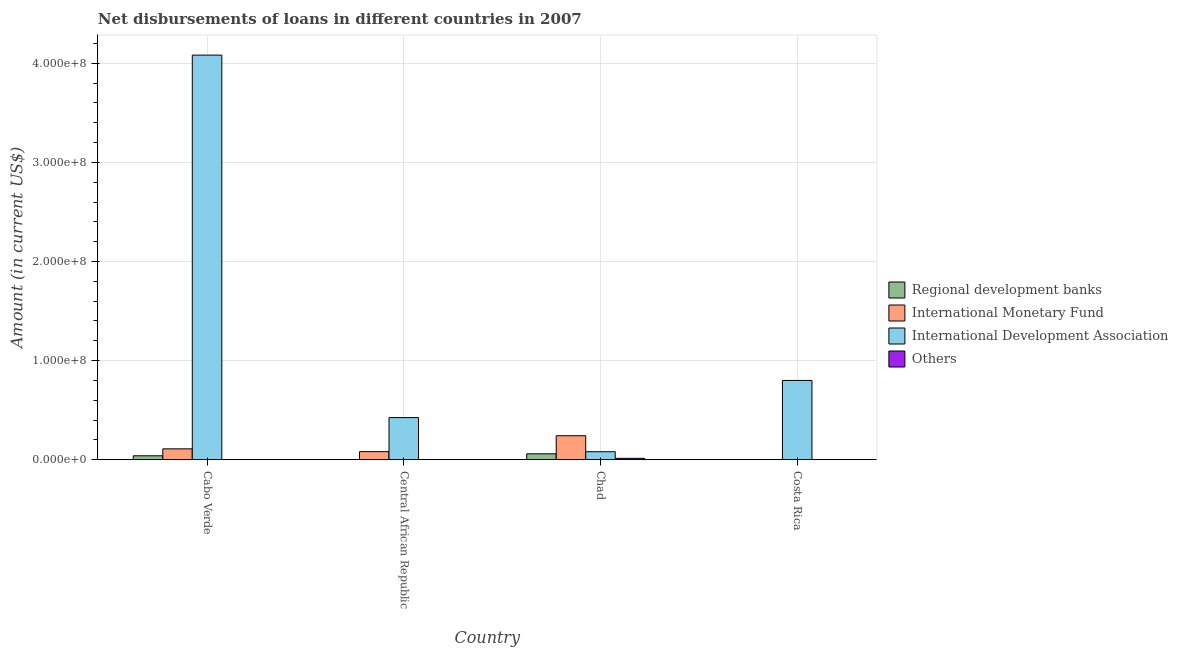How many different coloured bars are there?
Give a very brief answer. 4. Are the number of bars on each tick of the X-axis equal?
Offer a very short reply. No. How many bars are there on the 4th tick from the left?
Offer a terse response. 1. How many bars are there on the 4th tick from the right?
Your answer should be compact. 3. What is the label of the 2nd group of bars from the left?
Give a very brief answer. Central African Republic. In how many cases, is the number of bars for a given country not equal to the number of legend labels?
Your answer should be compact. 3. Across all countries, what is the maximum amount of loan disimbursed by international monetary fund?
Provide a short and direct response. 2.42e+07. In which country was the amount of loan disimbursed by international monetary fund maximum?
Ensure brevity in your answer.  Chad. What is the total amount of loan disimbursed by other organisations in the graph?
Your response must be concise. 1.40e+06. What is the difference between the amount of loan disimbursed by international monetary fund in Cabo Verde and that in Central African Republic?
Your answer should be very brief. 2.83e+06. What is the difference between the amount of loan disimbursed by international monetary fund in Central African Republic and the amount of loan disimbursed by other organisations in Cabo Verde?
Provide a succinct answer. 8.11e+06. What is the average amount of loan disimbursed by regional development banks per country?
Your answer should be very brief. 2.47e+06. What is the difference between the amount of loan disimbursed by regional development banks and amount of loan disimbursed by international development association in Chad?
Give a very brief answer. -2.12e+06. What is the ratio of the amount of loan disimbursed by international development association in Cabo Verde to that in Central African Republic?
Your answer should be compact. 9.61. Is the amount of loan disimbursed by international development association in Cabo Verde less than that in Chad?
Your answer should be compact. No. What is the difference between the highest and the second highest amount of loan disimbursed by international monetary fund?
Provide a succinct answer. 1.32e+07. What is the difference between the highest and the lowest amount of loan disimbursed by regional development banks?
Ensure brevity in your answer.  5.93e+06. In how many countries, is the amount of loan disimbursed by international development association greater than the average amount of loan disimbursed by international development association taken over all countries?
Ensure brevity in your answer.  1. Is the sum of the amount of loan disimbursed by international monetary fund in Central African Republic and Chad greater than the maximum amount of loan disimbursed by other organisations across all countries?
Ensure brevity in your answer.  Yes. Are the values on the major ticks of Y-axis written in scientific E-notation?
Offer a terse response. Yes. Does the graph contain any zero values?
Ensure brevity in your answer.  Yes. Where does the legend appear in the graph?
Provide a succinct answer. Center right. How many legend labels are there?
Provide a succinct answer. 4. How are the legend labels stacked?
Your answer should be very brief. Vertical. What is the title of the graph?
Make the answer very short. Net disbursements of loans in different countries in 2007. Does "Social Insurance" appear as one of the legend labels in the graph?
Keep it short and to the point. No. What is the Amount (in current US$) in Regional development banks in Cabo Verde?
Give a very brief answer. 3.94e+06. What is the Amount (in current US$) of International Monetary Fund in Cabo Verde?
Provide a short and direct response. 1.09e+07. What is the Amount (in current US$) in International Development Association in Cabo Verde?
Keep it short and to the point. 4.08e+08. What is the Amount (in current US$) of Others in Cabo Verde?
Give a very brief answer. 0. What is the Amount (in current US$) in Regional development banks in Central African Republic?
Give a very brief answer. 0. What is the Amount (in current US$) in International Monetary Fund in Central African Republic?
Keep it short and to the point. 8.11e+06. What is the Amount (in current US$) of International Development Association in Central African Republic?
Your response must be concise. 4.25e+07. What is the Amount (in current US$) of Others in Central African Republic?
Your answer should be compact. 0. What is the Amount (in current US$) of Regional development banks in Chad?
Provide a short and direct response. 5.93e+06. What is the Amount (in current US$) in International Monetary Fund in Chad?
Provide a short and direct response. 2.42e+07. What is the Amount (in current US$) of International Development Association in Chad?
Your answer should be very brief. 8.05e+06. What is the Amount (in current US$) of Others in Chad?
Keep it short and to the point. 1.40e+06. What is the Amount (in current US$) in International Development Association in Costa Rica?
Your answer should be compact. 8.00e+07. What is the Amount (in current US$) in Others in Costa Rica?
Your answer should be very brief. 0. Across all countries, what is the maximum Amount (in current US$) of Regional development banks?
Ensure brevity in your answer.  5.93e+06. Across all countries, what is the maximum Amount (in current US$) in International Monetary Fund?
Your answer should be very brief. 2.42e+07. Across all countries, what is the maximum Amount (in current US$) of International Development Association?
Keep it short and to the point. 4.08e+08. Across all countries, what is the maximum Amount (in current US$) in Others?
Keep it short and to the point. 1.40e+06. Across all countries, what is the minimum Amount (in current US$) in Regional development banks?
Give a very brief answer. 0. Across all countries, what is the minimum Amount (in current US$) in International Development Association?
Provide a short and direct response. 8.05e+06. Across all countries, what is the minimum Amount (in current US$) of Others?
Give a very brief answer. 0. What is the total Amount (in current US$) of Regional development banks in the graph?
Give a very brief answer. 9.87e+06. What is the total Amount (in current US$) of International Monetary Fund in the graph?
Provide a short and direct response. 4.33e+07. What is the total Amount (in current US$) of International Development Association in the graph?
Keep it short and to the point. 5.39e+08. What is the total Amount (in current US$) in Others in the graph?
Offer a terse response. 1.40e+06. What is the difference between the Amount (in current US$) in International Monetary Fund in Cabo Verde and that in Central African Republic?
Provide a short and direct response. 2.83e+06. What is the difference between the Amount (in current US$) of International Development Association in Cabo Verde and that in Central African Republic?
Keep it short and to the point. 3.66e+08. What is the difference between the Amount (in current US$) of Regional development banks in Cabo Verde and that in Chad?
Make the answer very short. -1.99e+06. What is the difference between the Amount (in current US$) of International Monetary Fund in Cabo Verde and that in Chad?
Make the answer very short. -1.32e+07. What is the difference between the Amount (in current US$) of International Development Association in Cabo Verde and that in Chad?
Your answer should be compact. 4.00e+08. What is the difference between the Amount (in current US$) in International Development Association in Cabo Verde and that in Costa Rica?
Your response must be concise. 3.28e+08. What is the difference between the Amount (in current US$) of International Monetary Fund in Central African Republic and that in Chad?
Keep it short and to the point. -1.61e+07. What is the difference between the Amount (in current US$) of International Development Association in Central African Republic and that in Chad?
Make the answer very short. 3.45e+07. What is the difference between the Amount (in current US$) in International Development Association in Central African Republic and that in Costa Rica?
Offer a very short reply. -3.75e+07. What is the difference between the Amount (in current US$) of International Development Association in Chad and that in Costa Rica?
Give a very brief answer. -7.19e+07. What is the difference between the Amount (in current US$) of Regional development banks in Cabo Verde and the Amount (in current US$) of International Monetary Fund in Central African Republic?
Your answer should be compact. -4.17e+06. What is the difference between the Amount (in current US$) of Regional development banks in Cabo Verde and the Amount (in current US$) of International Development Association in Central African Republic?
Keep it short and to the point. -3.86e+07. What is the difference between the Amount (in current US$) of International Monetary Fund in Cabo Verde and the Amount (in current US$) of International Development Association in Central African Republic?
Make the answer very short. -3.16e+07. What is the difference between the Amount (in current US$) of Regional development banks in Cabo Verde and the Amount (in current US$) of International Monetary Fund in Chad?
Your answer should be very brief. -2.02e+07. What is the difference between the Amount (in current US$) in Regional development banks in Cabo Verde and the Amount (in current US$) in International Development Association in Chad?
Provide a short and direct response. -4.10e+06. What is the difference between the Amount (in current US$) in Regional development banks in Cabo Verde and the Amount (in current US$) in Others in Chad?
Make the answer very short. 2.55e+06. What is the difference between the Amount (in current US$) of International Monetary Fund in Cabo Verde and the Amount (in current US$) of International Development Association in Chad?
Provide a succinct answer. 2.90e+06. What is the difference between the Amount (in current US$) of International Monetary Fund in Cabo Verde and the Amount (in current US$) of Others in Chad?
Provide a succinct answer. 9.55e+06. What is the difference between the Amount (in current US$) in International Development Association in Cabo Verde and the Amount (in current US$) in Others in Chad?
Keep it short and to the point. 4.07e+08. What is the difference between the Amount (in current US$) of Regional development banks in Cabo Verde and the Amount (in current US$) of International Development Association in Costa Rica?
Give a very brief answer. -7.61e+07. What is the difference between the Amount (in current US$) of International Monetary Fund in Cabo Verde and the Amount (in current US$) of International Development Association in Costa Rica?
Give a very brief answer. -6.91e+07. What is the difference between the Amount (in current US$) of International Monetary Fund in Central African Republic and the Amount (in current US$) of International Development Association in Chad?
Ensure brevity in your answer.  6.50e+04. What is the difference between the Amount (in current US$) in International Monetary Fund in Central African Republic and the Amount (in current US$) in Others in Chad?
Your answer should be compact. 6.72e+06. What is the difference between the Amount (in current US$) in International Development Association in Central African Republic and the Amount (in current US$) in Others in Chad?
Your answer should be very brief. 4.11e+07. What is the difference between the Amount (in current US$) of International Monetary Fund in Central African Republic and the Amount (in current US$) of International Development Association in Costa Rica?
Ensure brevity in your answer.  -7.19e+07. What is the difference between the Amount (in current US$) in Regional development banks in Chad and the Amount (in current US$) in International Development Association in Costa Rica?
Your response must be concise. -7.41e+07. What is the difference between the Amount (in current US$) of International Monetary Fund in Chad and the Amount (in current US$) of International Development Association in Costa Rica?
Give a very brief answer. -5.58e+07. What is the average Amount (in current US$) of Regional development banks per country?
Make the answer very short. 2.47e+06. What is the average Amount (in current US$) of International Monetary Fund per country?
Offer a very short reply. 1.08e+07. What is the average Amount (in current US$) of International Development Association per country?
Offer a terse response. 1.35e+08. What is the average Amount (in current US$) of Others per country?
Offer a terse response. 3.49e+05. What is the difference between the Amount (in current US$) in Regional development banks and Amount (in current US$) in International Monetary Fund in Cabo Verde?
Keep it short and to the point. -7.00e+06. What is the difference between the Amount (in current US$) in Regional development banks and Amount (in current US$) in International Development Association in Cabo Verde?
Provide a short and direct response. -4.04e+08. What is the difference between the Amount (in current US$) in International Monetary Fund and Amount (in current US$) in International Development Association in Cabo Verde?
Your response must be concise. -3.97e+08. What is the difference between the Amount (in current US$) in International Monetary Fund and Amount (in current US$) in International Development Association in Central African Republic?
Ensure brevity in your answer.  -3.44e+07. What is the difference between the Amount (in current US$) of Regional development banks and Amount (in current US$) of International Monetary Fund in Chad?
Your answer should be compact. -1.83e+07. What is the difference between the Amount (in current US$) in Regional development banks and Amount (in current US$) in International Development Association in Chad?
Make the answer very short. -2.12e+06. What is the difference between the Amount (in current US$) in Regional development banks and Amount (in current US$) in Others in Chad?
Provide a short and direct response. 4.53e+06. What is the difference between the Amount (in current US$) in International Monetary Fund and Amount (in current US$) in International Development Association in Chad?
Give a very brief answer. 1.61e+07. What is the difference between the Amount (in current US$) in International Monetary Fund and Amount (in current US$) in Others in Chad?
Provide a succinct answer. 2.28e+07. What is the difference between the Amount (in current US$) in International Development Association and Amount (in current US$) in Others in Chad?
Keep it short and to the point. 6.65e+06. What is the ratio of the Amount (in current US$) in International Monetary Fund in Cabo Verde to that in Central African Republic?
Provide a short and direct response. 1.35. What is the ratio of the Amount (in current US$) of International Development Association in Cabo Verde to that in Central African Republic?
Offer a terse response. 9.61. What is the ratio of the Amount (in current US$) in Regional development banks in Cabo Verde to that in Chad?
Provide a succinct answer. 0.67. What is the ratio of the Amount (in current US$) of International Monetary Fund in Cabo Verde to that in Chad?
Your answer should be very brief. 0.45. What is the ratio of the Amount (in current US$) of International Development Association in Cabo Verde to that in Chad?
Offer a terse response. 50.73. What is the ratio of the Amount (in current US$) in International Development Association in Cabo Verde to that in Costa Rica?
Provide a succinct answer. 5.1. What is the ratio of the Amount (in current US$) in International Monetary Fund in Central African Republic to that in Chad?
Your answer should be compact. 0.34. What is the ratio of the Amount (in current US$) in International Development Association in Central African Republic to that in Chad?
Offer a very short reply. 5.28. What is the ratio of the Amount (in current US$) of International Development Association in Central African Republic to that in Costa Rica?
Provide a succinct answer. 0.53. What is the ratio of the Amount (in current US$) of International Development Association in Chad to that in Costa Rica?
Keep it short and to the point. 0.1. What is the difference between the highest and the second highest Amount (in current US$) in International Monetary Fund?
Your response must be concise. 1.32e+07. What is the difference between the highest and the second highest Amount (in current US$) in International Development Association?
Provide a short and direct response. 3.28e+08. What is the difference between the highest and the lowest Amount (in current US$) in Regional development banks?
Your answer should be compact. 5.93e+06. What is the difference between the highest and the lowest Amount (in current US$) in International Monetary Fund?
Offer a terse response. 2.42e+07. What is the difference between the highest and the lowest Amount (in current US$) in International Development Association?
Ensure brevity in your answer.  4.00e+08. What is the difference between the highest and the lowest Amount (in current US$) of Others?
Your answer should be compact. 1.40e+06. 